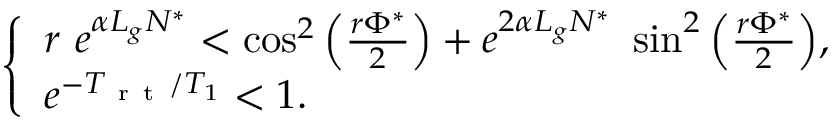<formula> <loc_0><loc_0><loc_500><loc_500>\begin{array} { r } { \left \{ \begin{array} { l l } { r \ e ^ { \alpha L _ { g } N ^ { * } } < \cos ^ { 2 } \left ( \frac { r \Phi ^ { * } } { 2 } \right ) + e ^ { 2 \alpha L _ { g } N ^ { * } } \ \sin ^ { 2 } \left ( \frac { r \Phi ^ { * } } { 2 } \right ) , } \\ { e ^ { - T _ { r t } / T _ { 1 } } < 1 . } \end{array} } \end{array}</formula> 